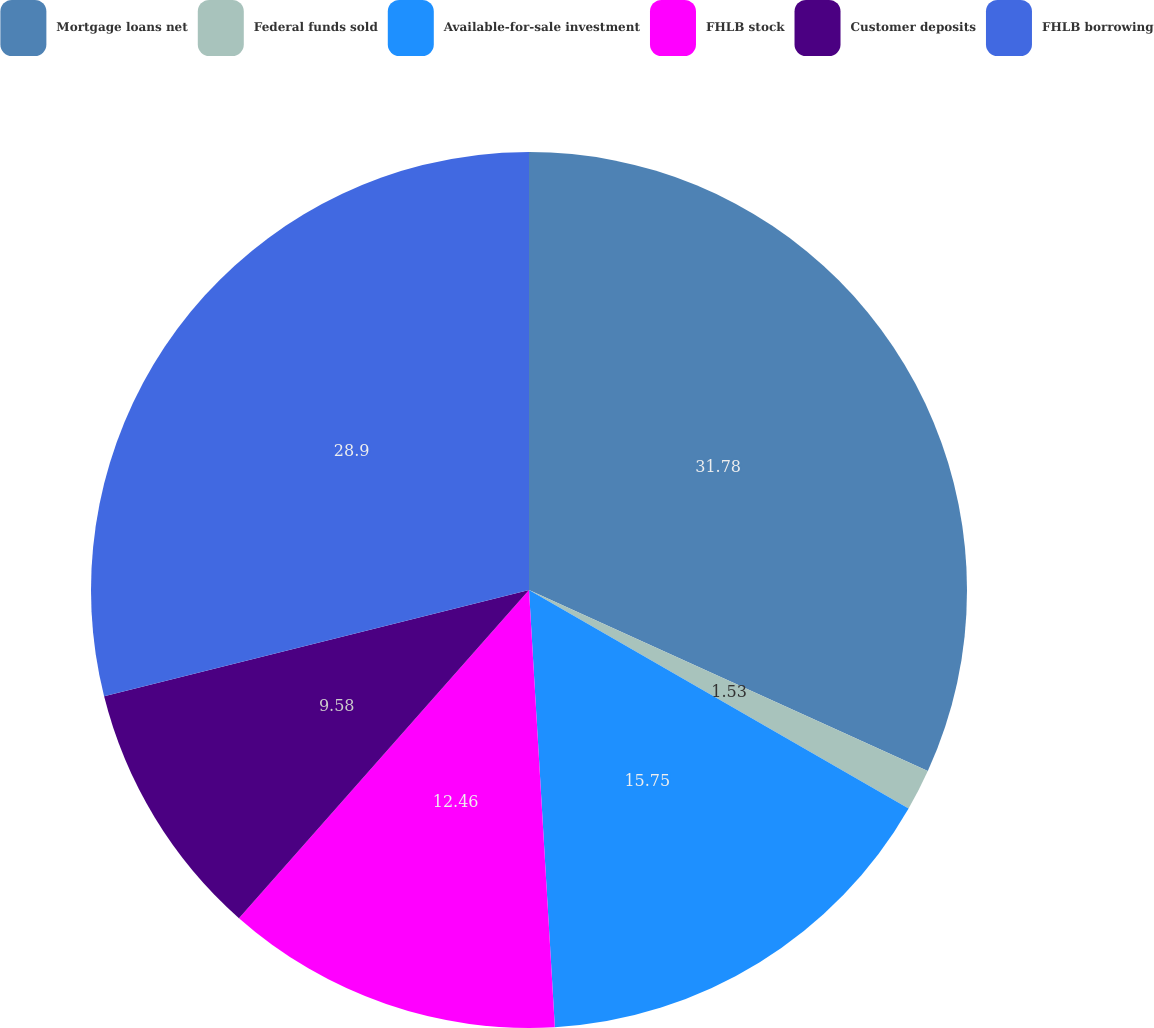<chart> <loc_0><loc_0><loc_500><loc_500><pie_chart><fcel>Mortgage loans net<fcel>Federal funds sold<fcel>Available-for-sale investment<fcel>FHLB stock<fcel>Customer deposits<fcel>FHLB borrowing<nl><fcel>31.79%<fcel>1.53%<fcel>15.75%<fcel>12.46%<fcel>9.58%<fcel>28.91%<nl></chart> 